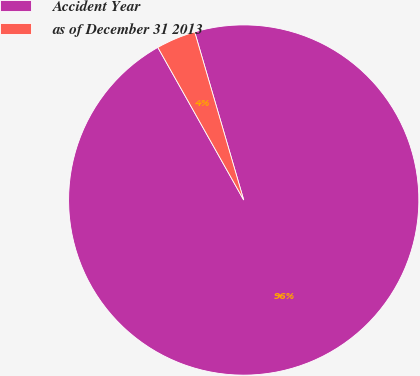Convert chart. <chart><loc_0><loc_0><loc_500><loc_500><pie_chart><fcel>Accident Year<fcel>as of December 31 2013<nl><fcel>96.36%<fcel>3.64%<nl></chart> 